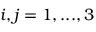Convert formula to latex. <formula><loc_0><loc_0><loc_500><loc_500>i , j = 1 , \dots , 3</formula> 